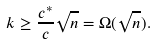Convert formula to latex. <formula><loc_0><loc_0><loc_500><loc_500>k \geq \frac { c ^ { * } } { c } \sqrt { n } = \Omega ( \sqrt { n } ) .</formula> 